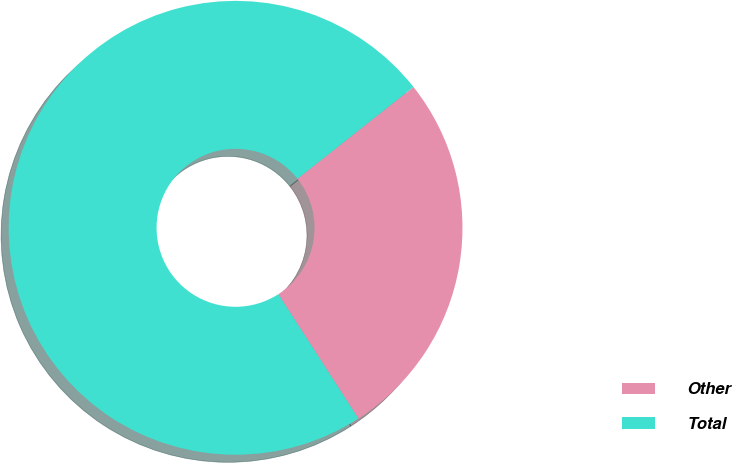Convert chart to OTSL. <chart><loc_0><loc_0><loc_500><loc_500><pie_chart><fcel>Other<fcel>Total<nl><fcel>26.55%<fcel>73.45%<nl></chart> 